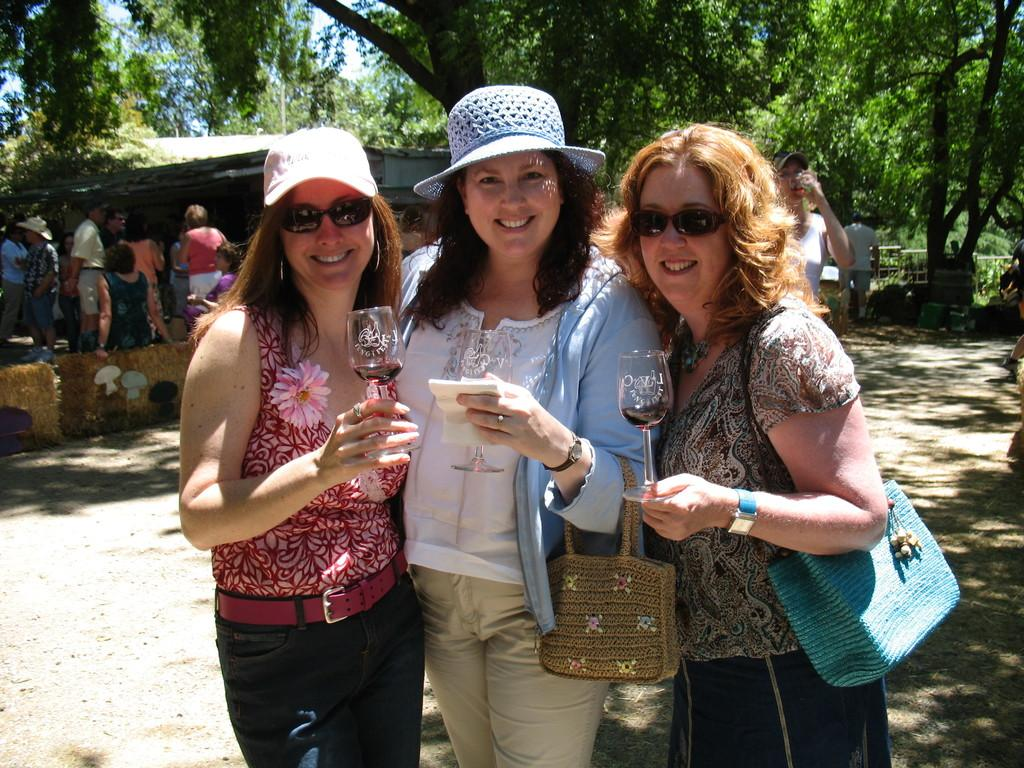Who or what is present in the image? There are people in the image. What are the people holding in their hands? The people are holding glasses. What type of natural environment can be seen in the image? There are trees in the image. What type of structure is visible in the image? There is a house in the image. What is visible in the background of the image? The sky is visible in the image. What type of cushion is being used by the people in the image? There is no cushion visible in the image; the people are holding glasses. 